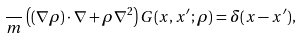Convert formula to latex. <formula><loc_0><loc_0><loc_500><loc_500>\frac { } { m } \left ( ( \nabla \rho ) \cdot \nabla + \rho \nabla ^ { 2 } \right ) G ( { x } , { x } ^ { \prime } ; \rho ) = \delta ( { x } - { x } ^ { \prime } ) ,</formula> 